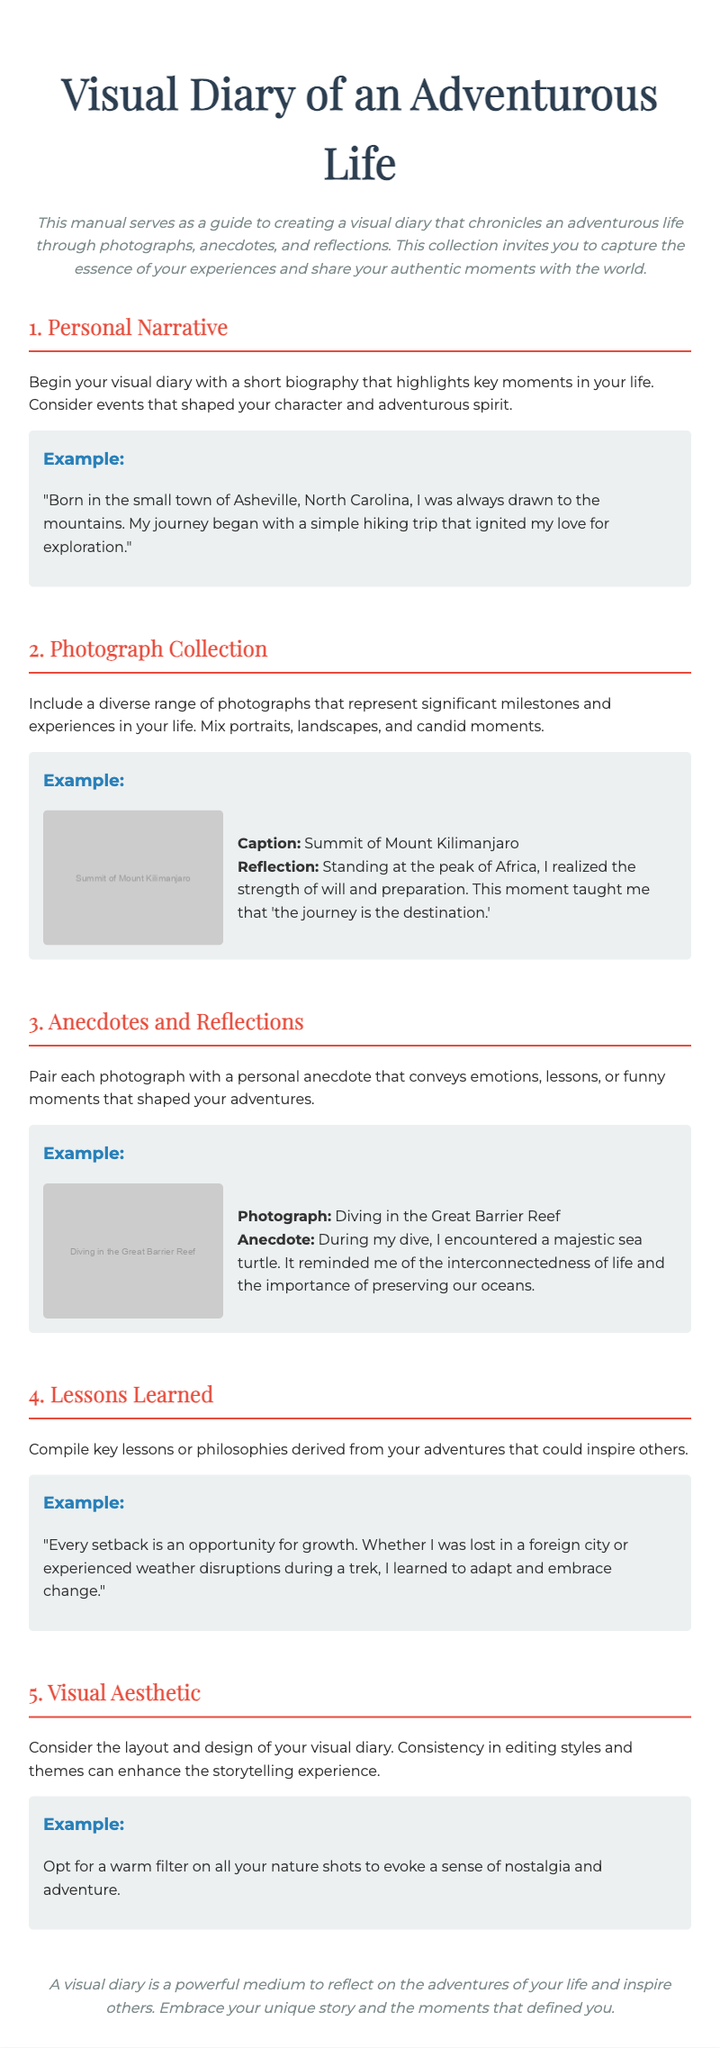What is the title of the manual? The title is presented prominently at the top of the document.
Answer: Visual Diary of an Adventurous Life What is the main purpose of the manual? The introduction specifies the main aim of the document.
Answer: Guide to creating a visual diary Which city is mentioned in the personal narrative example? The personal narrative example provides details about the author's background.
Answer: Asheville What significant location is featured in the photograph example? The photograph example highlights a noteworthy experience captured visually.
Answer: Summit of Mount Kilimanjaro What is a key lesson learned as stated in the manual? The section on lessons learned provides philosophical insights derived from experiences.
Answer: Every setback is an opportunity for growth How should photographs be edited according to the visual aesthetic section? This section includes guidance on editing styles for photographs.
Answer: Warm filter What type of photographs should be included in the diary? The document specifies what kind of photographs to include.
Answer: Diverse range of photographs What key element should pair with each photograph? The document outlines what is necessary alongside the photos in the visual diary.
Answer: Personal anecdote 